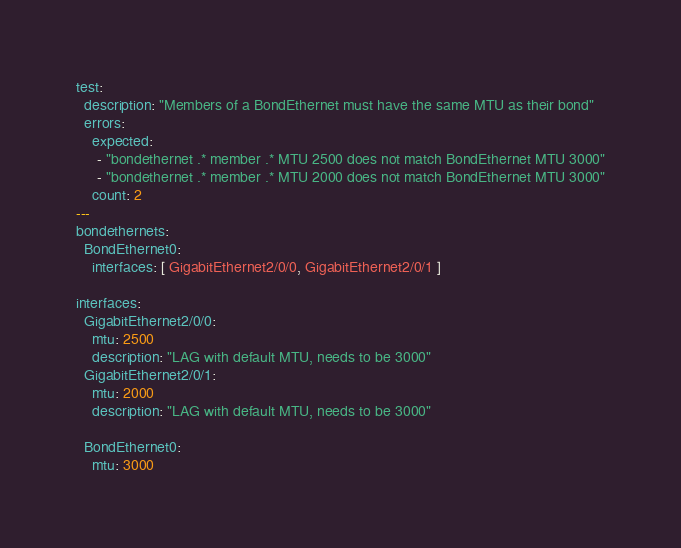Convert code to text. <code><loc_0><loc_0><loc_500><loc_500><_YAML_>test:
  description: "Members of a BondEthernet must have the same MTU as their bond"
  errors:
    expected:
     - "bondethernet .* member .* MTU 2500 does not match BondEthernet MTU 3000"
     - "bondethernet .* member .* MTU 2000 does not match BondEthernet MTU 3000"
    count: 2
---
bondethernets:
  BondEthernet0:
    interfaces: [ GigabitEthernet2/0/0, GigabitEthernet2/0/1 ]

interfaces:
  GigabitEthernet2/0/0:
    mtu: 2500
    description: "LAG with default MTU, needs to be 3000"
  GigabitEthernet2/0/1:
    mtu: 2000
    description: "LAG with default MTU, needs to be 3000"

  BondEthernet0:
    mtu: 3000
</code> 